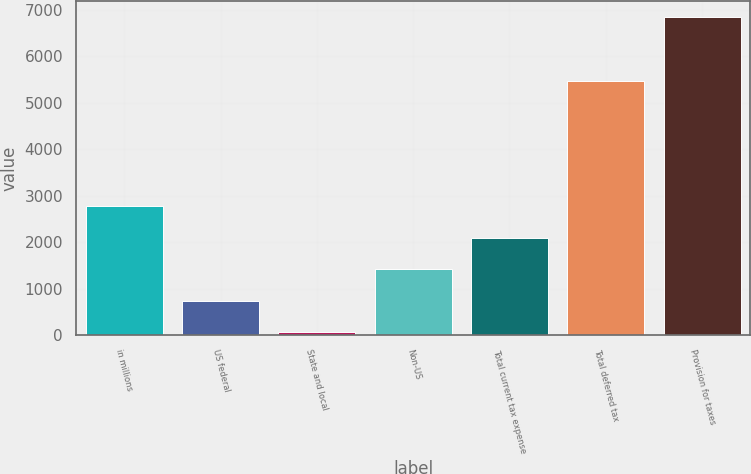Convert chart to OTSL. <chart><loc_0><loc_0><loc_500><loc_500><bar_chart><fcel>in millions<fcel>US federal<fcel>State and local<fcel>Non-US<fcel>Total current tax expense<fcel>Total deferred tax<fcel>Provision for taxes<nl><fcel>2776.8<fcel>742.2<fcel>64<fcel>1420.4<fcel>2098.6<fcel>5458<fcel>6846<nl></chart> 